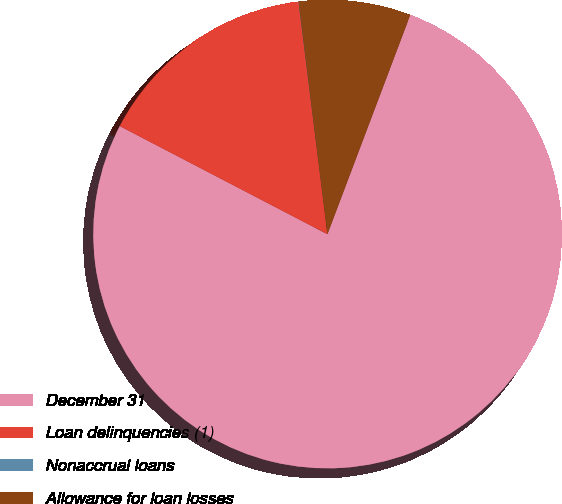Convert chart. <chart><loc_0><loc_0><loc_500><loc_500><pie_chart><fcel>December 31<fcel>Loan delinquencies (1)<fcel>Nonaccrual loans<fcel>Allowance for loan losses<nl><fcel>76.89%<fcel>15.39%<fcel>0.02%<fcel>7.7%<nl></chart> 